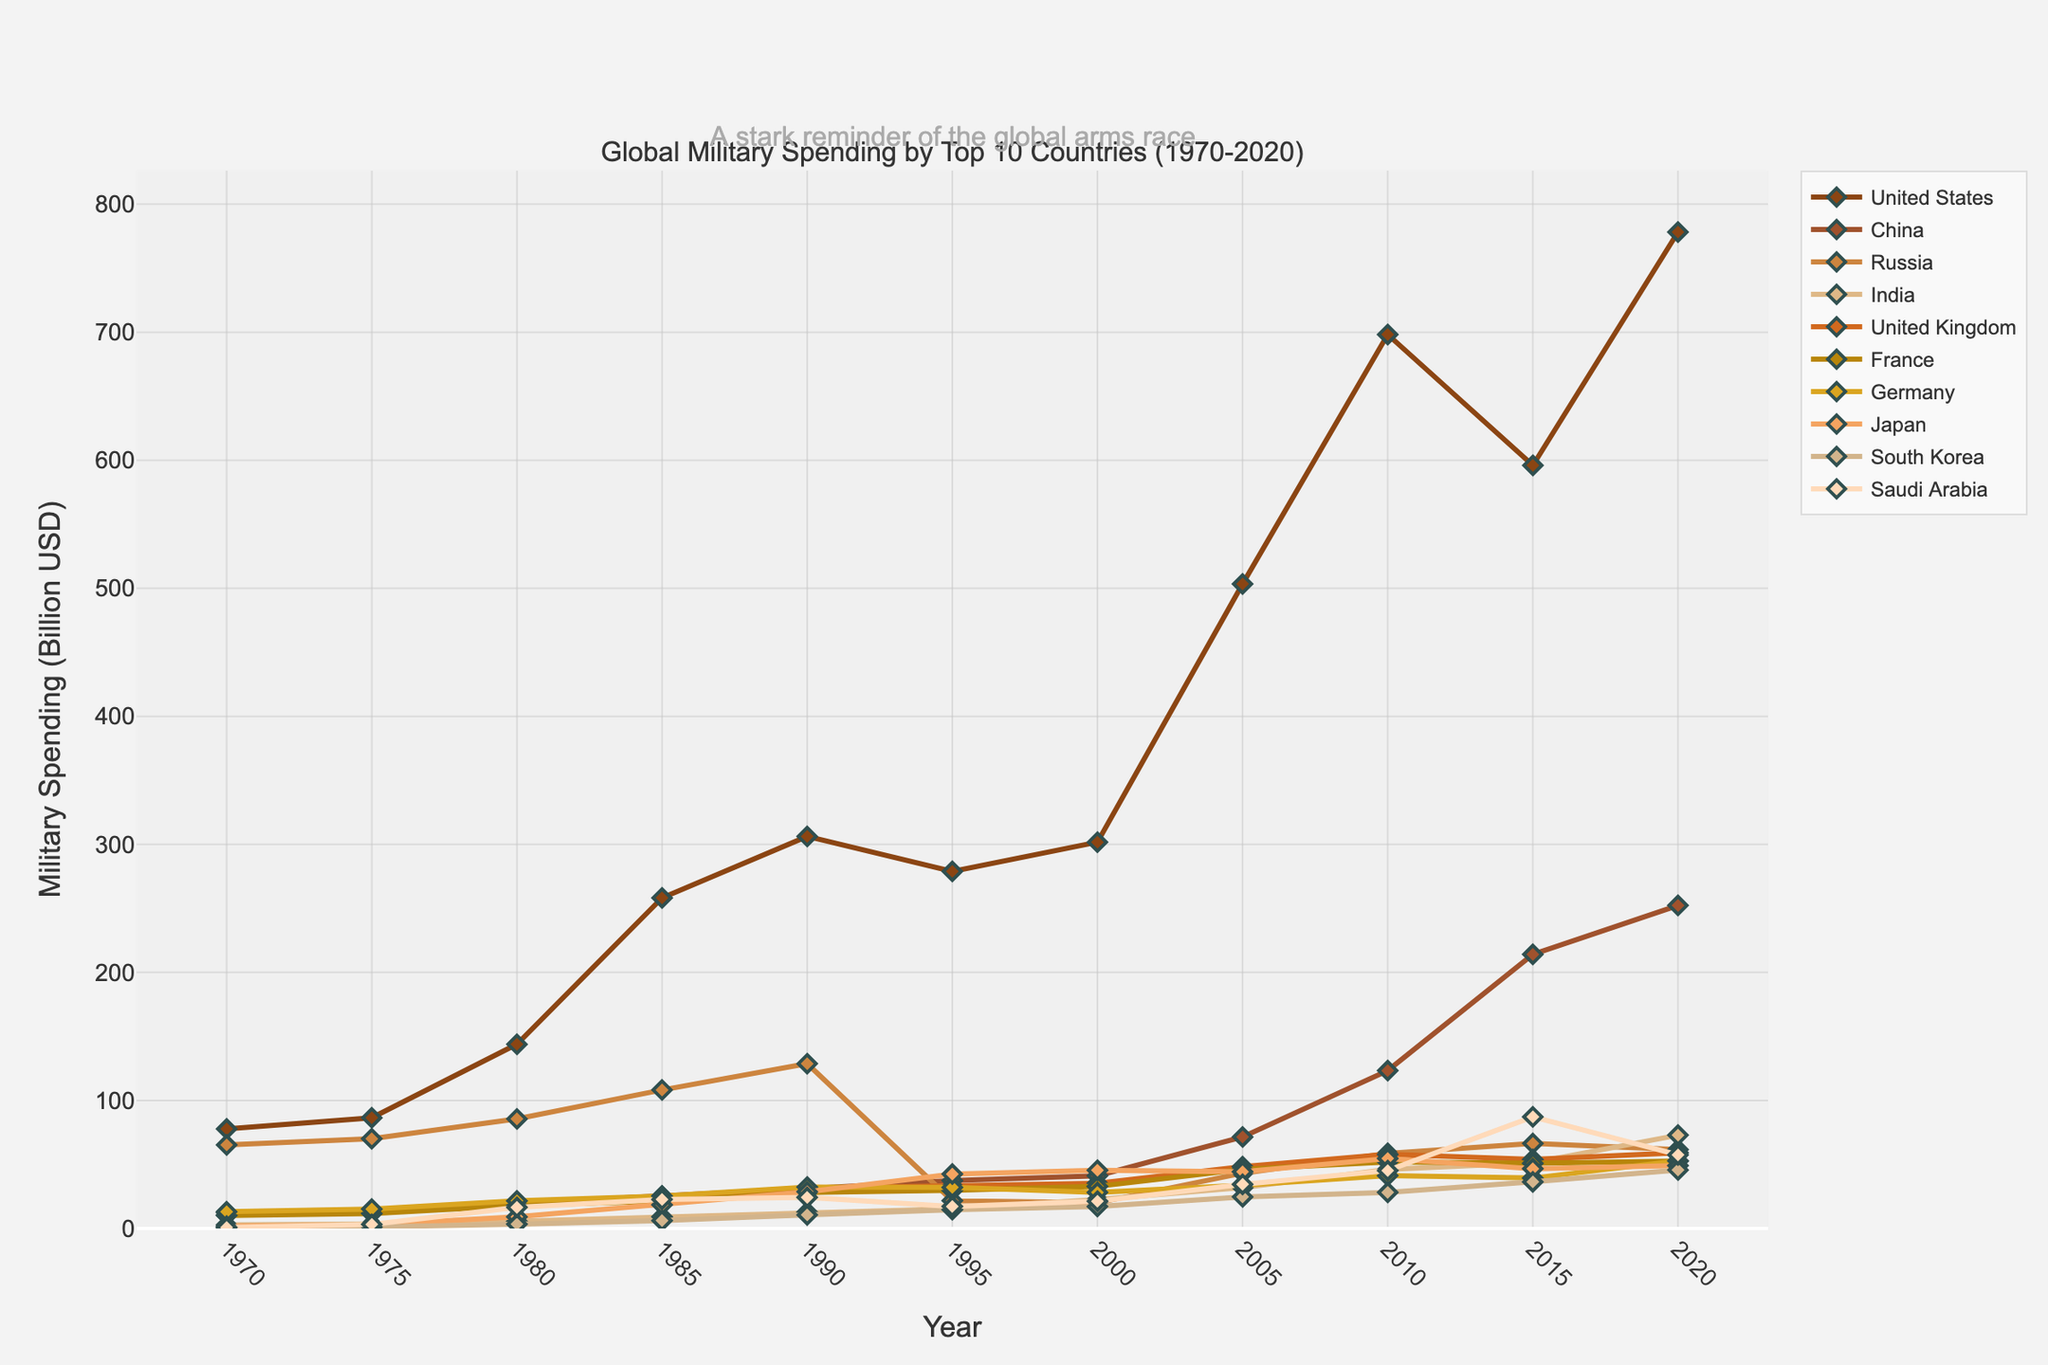Which country has the highest military spending in 2020? Observing the figure, the United States has the highest military spending in 2020 as its line is the highest over the "Year = 2020" marker
Answer: United States How did China's military spending change from 1980 to 2020? The figure shows that China's military spending increased from around 19.8 billion USD in 1980 to 252.3 billion USD in 2020, indicating a significant rise
Answer: Increased Which countries' military spending decreased between 2015 and 2020? By comparing the lines' positions at 2015 and 2020, we notice that Russia’s spending decreases from 66.4 billion USD in 2015 to 61.7 billion USD in 2020
Answer: Russia What was the approximate average military spending of the United Kingdom in the decades of the 1980s and 1990s? Summing the spending for 1980, 1985, 1990, and 1995 (20.5 + 24.8 + 31.5 + 33.2) and dividing by four to obtain the average, we get (110 / 4) billion USD
Answer: 27.5 billion USD Which two countries had close military spending values in 2020 and significantly lower than the United States? Examining the 2020 part of the graph, both France and Germany have similar military spending values around 52-53 billion USD, much lower than the 778.2 billion USD of the United States
Answer: France and Germany When did Saudi Arabia see the largest spike in military spending? Checking Saudi Arabia’s line, the largest increase is visible between 2010 and 2015, rising from around 45.2 billion USD to 87.2 billion USD
Answer: 2010-2015 By how much did the United States' military spending increase from 1970 to 1985? Refer to the figure where in 1970 the spending was 77.8 billion USD and in 1985 it was 258.2 billion USD, making the increase (258.2 - 77.8) billion USD
Answer: 180.4 billion USD Compare the military spending of India and Japan in 2000. Which one was higher and by how much? Looking at the 2000 data points, Japan's spending was 45.5 billion USD while India's was 22.7 billion USD. The difference is (45.5 - 22.7) billion USD
Answer: Japan, 22.8 billion USD What visual trend can be observed in Russia's military spending from 1990 to 2000? Russia's line sharply descends after 1990 till 1995 and slightly rises again but remains lower overall compared to 1990
Answer: Declining then slightly rising but overall lower Identify the period when the United States' military spending was relatively stable. Observing the graph, there’s a relatively stable period between 1990 and 2000 when the line slightly fluctuates but does not show large changes
Answer: 1990-2000 